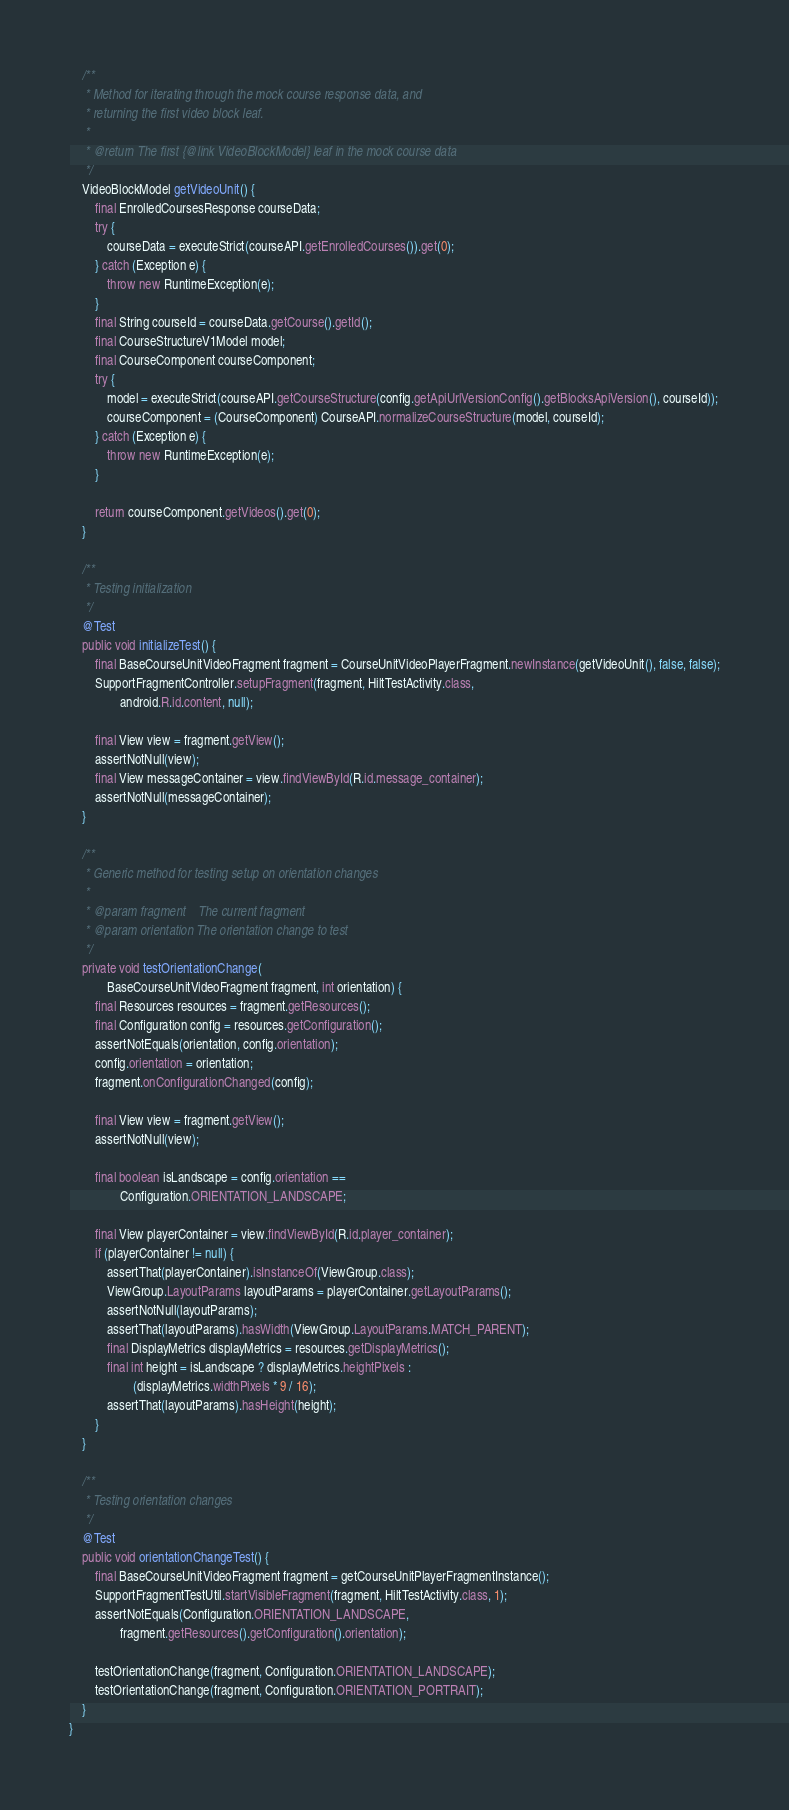Convert code to text. <code><loc_0><loc_0><loc_500><loc_500><_Java_>    /**
     * Method for iterating through the mock course response data, and
     * returning the first video block leaf.
     *
     * @return The first {@link VideoBlockModel} leaf in the mock course data
     */
    VideoBlockModel getVideoUnit() {
        final EnrolledCoursesResponse courseData;
        try {
            courseData = executeStrict(courseAPI.getEnrolledCourses()).get(0);
        } catch (Exception e) {
            throw new RuntimeException(e);
        }
        final String courseId = courseData.getCourse().getId();
        final CourseStructureV1Model model;
        final CourseComponent courseComponent;
        try {
            model = executeStrict(courseAPI.getCourseStructure(config.getApiUrlVersionConfig().getBlocksApiVersion(), courseId));
            courseComponent = (CourseComponent) CourseAPI.normalizeCourseStructure(model, courseId);
        } catch (Exception e) {
            throw new RuntimeException(e);
        }

        return courseComponent.getVideos().get(0);
    }

    /**
     * Testing initialization
     */
    @Test
    public void initializeTest() {
        final BaseCourseUnitVideoFragment fragment = CourseUnitVideoPlayerFragment.newInstance(getVideoUnit(), false, false);
        SupportFragmentController.setupFragment(fragment, HiltTestActivity.class,
                android.R.id.content, null);

        final View view = fragment.getView();
        assertNotNull(view);
        final View messageContainer = view.findViewById(R.id.message_container);
        assertNotNull(messageContainer);
    }

    /**
     * Generic method for testing setup on orientation changes
     *
     * @param fragment    The current fragment
     * @param orientation The orientation change to test
     */
    private void testOrientationChange(
            BaseCourseUnitVideoFragment fragment, int orientation) {
        final Resources resources = fragment.getResources();
        final Configuration config = resources.getConfiguration();
        assertNotEquals(orientation, config.orientation);
        config.orientation = orientation;
        fragment.onConfigurationChanged(config);

        final View view = fragment.getView();
        assertNotNull(view);

        final boolean isLandscape = config.orientation ==
                Configuration.ORIENTATION_LANDSCAPE;

        final View playerContainer = view.findViewById(R.id.player_container);
        if (playerContainer != null) {
            assertThat(playerContainer).isInstanceOf(ViewGroup.class);
            ViewGroup.LayoutParams layoutParams = playerContainer.getLayoutParams();
            assertNotNull(layoutParams);
            assertThat(layoutParams).hasWidth(ViewGroup.LayoutParams.MATCH_PARENT);
            final DisplayMetrics displayMetrics = resources.getDisplayMetrics();
            final int height = isLandscape ? displayMetrics.heightPixels :
                    (displayMetrics.widthPixels * 9 / 16);
            assertThat(layoutParams).hasHeight(height);
        }
    }

    /**
     * Testing orientation changes
     */
    @Test
    public void orientationChangeTest() {
        final BaseCourseUnitVideoFragment fragment = getCourseUnitPlayerFragmentInstance();
        SupportFragmentTestUtil.startVisibleFragment(fragment, HiltTestActivity.class, 1);
        assertNotEquals(Configuration.ORIENTATION_LANDSCAPE,
                fragment.getResources().getConfiguration().orientation);

        testOrientationChange(fragment, Configuration.ORIENTATION_LANDSCAPE);
        testOrientationChange(fragment, Configuration.ORIENTATION_PORTRAIT);
    }
}
</code> 